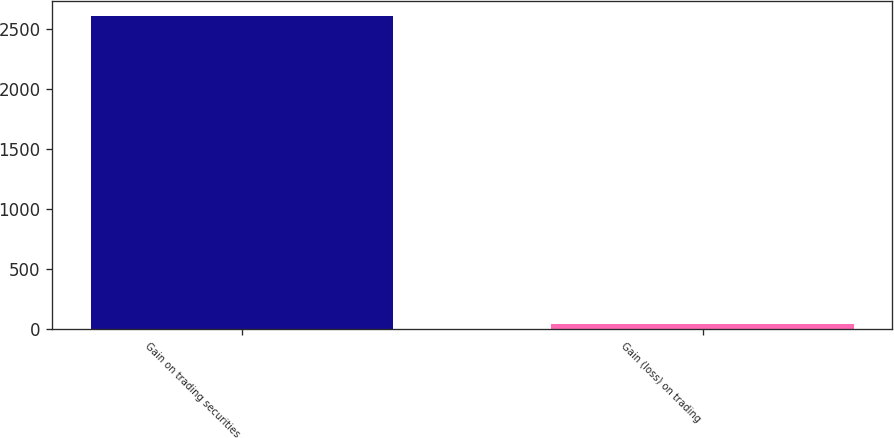<chart> <loc_0><loc_0><loc_500><loc_500><bar_chart><fcel>Gain on trading securities<fcel>Gain (loss) on trading<nl><fcel>2604<fcel>44<nl></chart> 